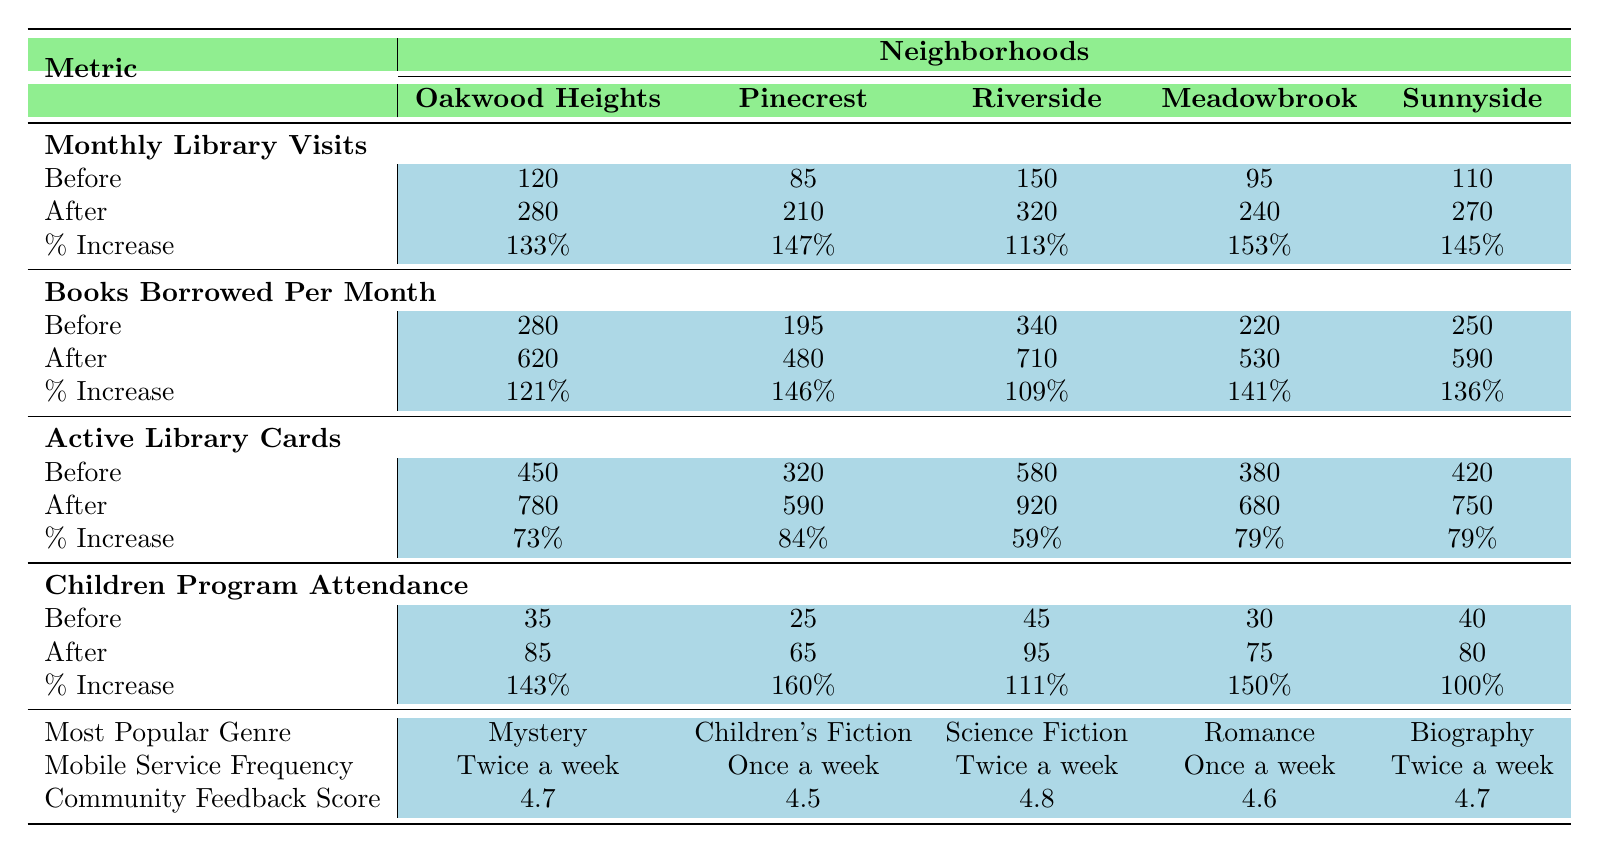What is the percentage increase in monthly library visits in Oakwood Heights? According to the table, the monthly library visits before mobile service implementation in Oakwood Heights were 120. After implementation, they rose to 280. The percentage increase is calculated as ((280 - 120) / 120) * 100 = 133%.
Answer: 133% What were the active library cards before mobile service in Riverside? The table shows that before mobile service implementation, Riverside had 580 active library cards.
Answer: 580 Which neighborhood had the highest increase in children program attendance? The children program attendance increased from 45 to 95 in Riverside, equating to a percentage increase of 111%, while in Pinecrest, the attendance rose from 25 to 65, which is a percentage increase of 160%. Pinecrest had the highest increase.
Answer: Pinecrest What is the average number of books borrowed per month after mobile service for all neighborhoods? Adding the number of books borrowed after mobile service for all neighborhoods: 620 + 480 + 710 + 530 + 590 = 3130. There are 5 neighborhoods, so the average is 3130 / 5 = 626.
Answer: 626 True or False: The community feedback score for Meadowbrook was the highest among all neighborhoods. The table lists the community feedback score for Meadowbrook as 4.6, which is lower than the scores for Riverside (4.8) and Oakwood Heights (4.7), so Meadowbrook does not have the highest score.
Answer: False Which neighborhood had the least increase in active library cards? Looking at the percentage increases, Riverside had a 59% increase in active library cards (from 580 to 920), while the other neighborhoods showed higher percentages: Oakwood Heights 73%, Pinecrest 84%, Meadowbrook 79%, and Sunnyside 79%. Thus, Riverside had the least increase.
Answer: Riverside How many more books were borrowed per month in Sunnyside after the mobile service than before? The number of books borrowed per month in Sunnyside before was 250, and after the implementation it was 590. The difference is 590 - 250 = 340.
Answer: 340 Which genre was the most popular in Riverside post-mobile service? The table lists "Science Fiction" as the most popular genre in Riverside.
Answer: Science Fiction What is the total change in monthly library visits across all neighborhoods before and after the mobile service? Before the mobile service, total monthly visits were: 120 + 85 + 150 + 95 + 110 = 560. After implementing the service, total visits were: 280 + 210 + 320 + 240 + 270 = 1320. The change is 1320 - 560 = 760.
Answer: 760 Which neighborhood had the highest books borrowed per month after the mobile service? In the table, after mobile implementation, Riverside had the highest books borrowed per month at 710.
Answer: Riverside 